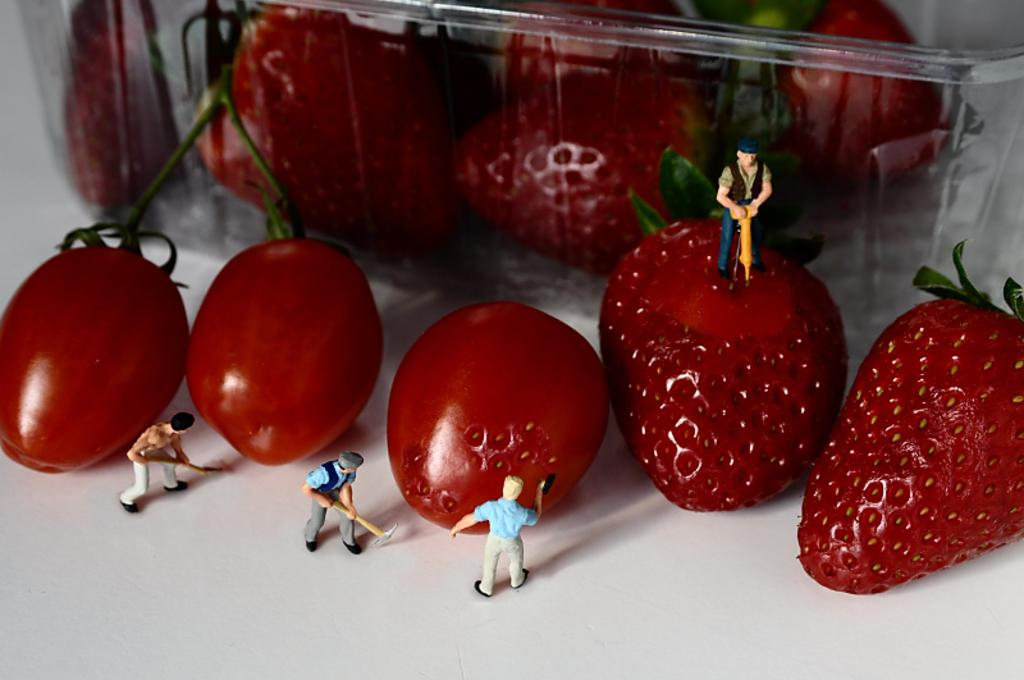What type of food items are present in the image? There are fruits in the image. How are the fruits arranged or contained in the image? The fruits are in a plastic box. What other items can be seen in the image besides the fruits? There are toys in the image. What type of egg is being used to express anger in the image? There is no egg or expression of anger present in the image. 